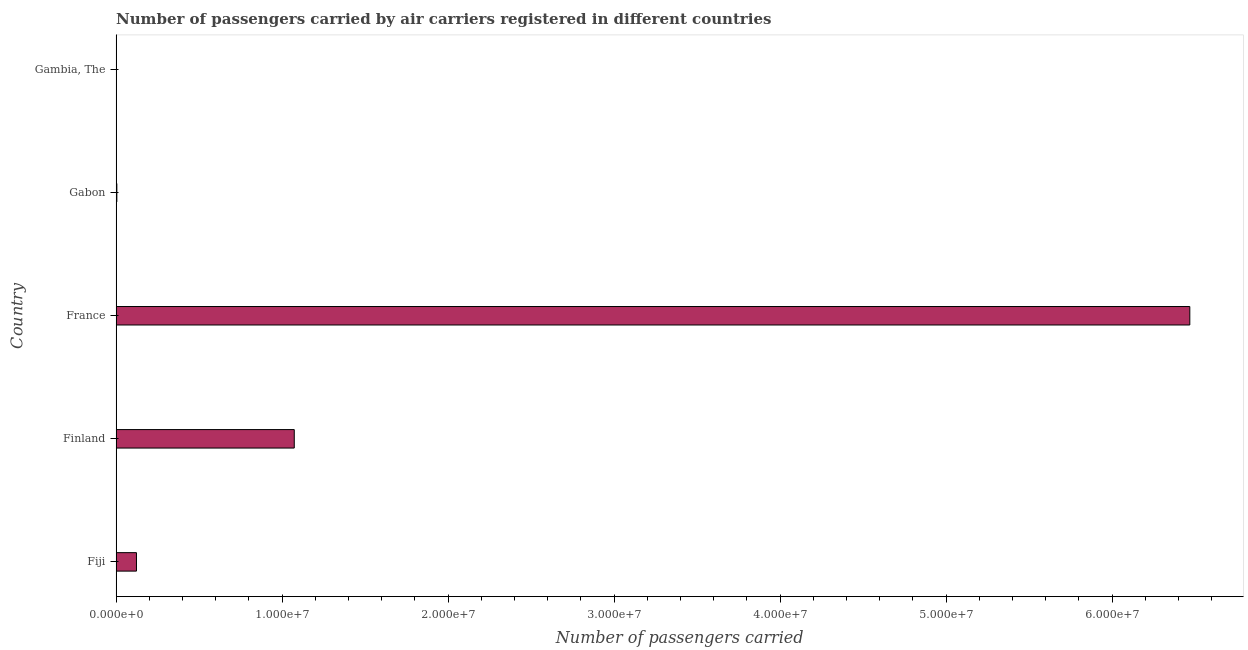Does the graph contain any zero values?
Give a very brief answer. No. Does the graph contain grids?
Your answer should be compact. No. What is the title of the graph?
Give a very brief answer. Number of passengers carried by air carriers registered in different countries. What is the label or title of the X-axis?
Provide a succinct answer. Number of passengers carried. What is the label or title of the Y-axis?
Your answer should be very brief. Country. What is the number of passengers carried in Finland?
Ensure brevity in your answer.  1.07e+07. Across all countries, what is the maximum number of passengers carried?
Keep it short and to the point. 6.47e+07. Across all countries, what is the minimum number of passengers carried?
Ensure brevity in your answer.  1.13e+04. In which country was the number of passengers carried minimum?
Ensure brevity in your answer.  Gambia, The. What is the sum of the number of passengers carried?
Your answer should be very brief. 7.67e+07. What is the difference between the number of passengers carried in Fiji and Gabon?
Offer a terse response. 1.18e+06. What is the average number of passengers carried per country?
Offer a terse response. 1.53e+07. What is the median number of passengers carried?
Keep it short and to the point. 1.23e+06. In how many countries, is the number of passengers carried greater than 12000000 ?
Give a very brief answer. 1. What is the ratio of the number of passengers carried in Gabon to that in Gambia, The?
Your answer should be very brief. 3.79. Is the number of passengers carried in Finland less than that in Gambia, The?
Provide a succinct answer. No. Is the difference between the number of passengers carried in France and Gabon greater than the difference between any two countries?
Your answer should be compact. No. What is the difference between the highest and the second highest number of passengers carried?
Keep it short and to the point. 5.40e+07. What is the difference between the highest and the lowest number of passengers carried?
Provide a short and direct response. 6.47e+07. How many bars are there?
Your answer should be compact. 5. Are all the bars in the graph horizontal?
Your answer should be compact. Yes. What is the Number of passengers carried in Fiji?
Keep it short and to the point. 1.23e+06. What is the Number of passengers carried of Finland?
Your answer should be compact. 1.07e+07. What is the Number of passengers carried of France?
Ensure brevity in your answer.  6.47e+07. What is the Number of passengers carried of Gabon?
Provide a succinct answer. 4.27e+04. What is the Number of passengers carried in Gambia, The?
Provide a succinct answer. 1.13e+04. What is the difference between the Number of passengers carried in Fiji and Finland?
Your answer should be compact. -9.51e+06. What is the difference between the Number of passengers carried in Fiji and France?
Provide a short and direct response. -6.35e+07. What is the difference between the Number of passengers carried in Fiji and Gabon?
Provide a succinct answer. 1.18e+06. What is the difference between the Number of passengers carried in Fiji and Gambia, The?
Your answer should be very brief. 1.21e+06. What is the difference between the Number of passengers carried in Finland and France?
Ensure brevity in your answer.  -5.40e+07. What is the difference between the Number of passengers carried in Finland and Gabon?
Your answer should be compact. 1.07e+07. What is the difference between the Number of passengers carried in Finland and Gambia, The?
Give a very brief answer. 1.07e+07. What is the difference between the Number of passengers carried in France and Gabon?
Give a very brief answer. 6.46e+07. What is the difference between the Number of passengers carried in France and Gambia, The?
Your response must be concise. 6.47e+07. What is the difference between the Number of passengers carried in Gabon and Gambia, The?
Your answer should be very brief. 3.14e+04. What is the ratio of the Number of passengers carried in Fiji to that in Finland?
Provide a succinct answer. 0.11. What is the ratio of the Number of passengers carried in Fiji to that in France?
Your response must be concise. 0.02. What is the ratio of the Number of passengers carried in Fiji to that in Gabon?
Make the answer very short. 28.68. What is the ratio of the Number of passengers carried in Fiji to that in Gambia, The?
Your answer should be compact. 108.58. What is the ratio of the Number of passengers carried in Finland to that in France?
Your answer should be compact. 0.17. What is the ratio of the Number of passengers carried in Finland to that in Gabon?
Offer a terse response. 251.16. What is the ratio of the Number of passengers carried in Finland to that in Gambia, The?
Ensure brevity in your answer.  951.07. What is the ratio of the Number of passengers carried in France to that in Gabon?
Provide a succinct answer. 1513.8. What is the ratio of the Number of passengers carried in France to that in Gambia, The?
Offer a very short reply. 5732.34. What is the ratio of the Number of passengers carried in Gabon to that in Gambia, The?
Give a very brief answer. 3.79. 